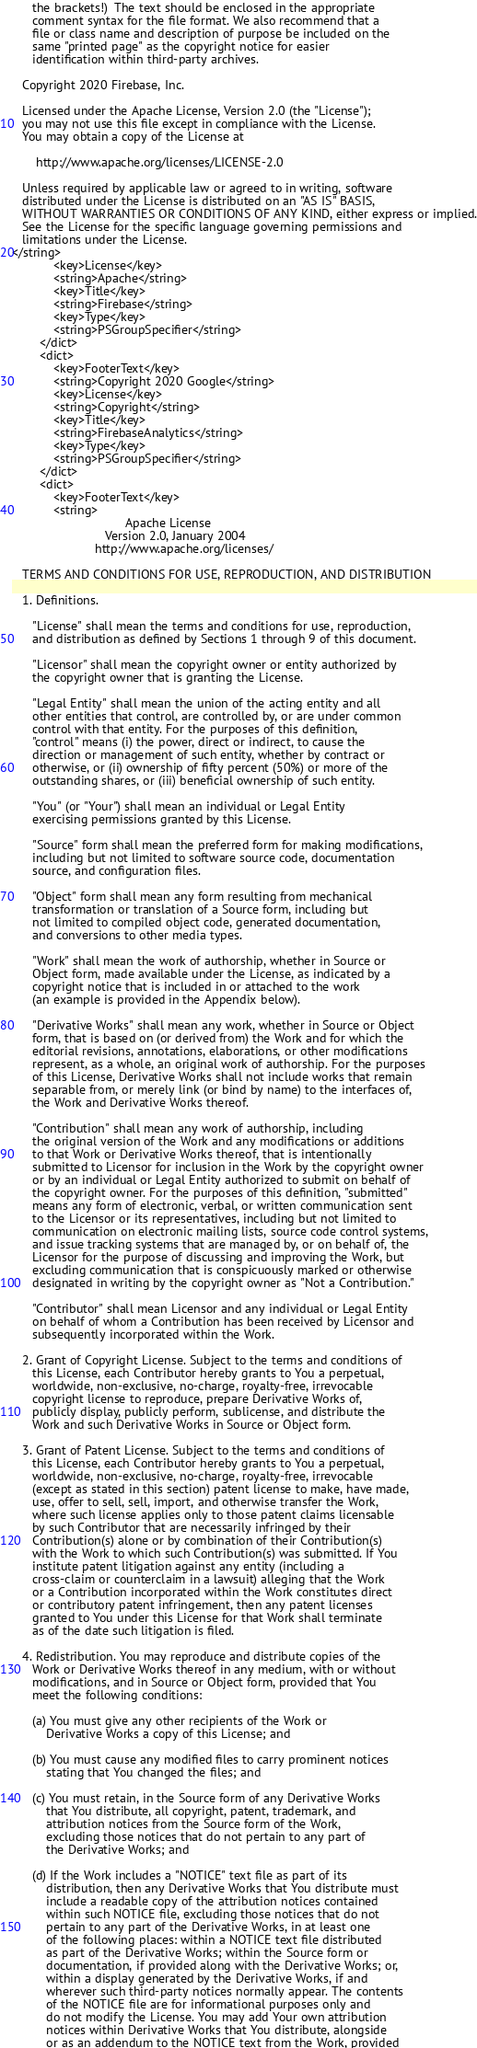Convert code to text. <code><loc_0><loc_0><loc_500><loc_500><_XML_>      the brackets!)  The text should be enclosed in the appropriate
      comment syntax for the file format. We also recommend that a
      file or class name and description of purpose be included on the
      same "printed page" as the copyright notice for easier
      identification within third-party archives.

   Copyright 2020 Firebase, Inc.

   Licensed under the Apache License, Version 2.0 (the "License");
   you may not use this file except in compliance with the License.
   You may obtain a copy of the License at

       http://www.apache.org/licenses/LICENSE-2.0

   Unless required by applicable law or agreed to in writing, software
   distributed under the License is distributed on an "AS IS" BASIS,
   WITHOUT WARRANTIES OR CONDITIONS OF ANY KIND, either express or implied.
   See the License for the specific language governing permissions and
   limitations under the License.
</string>
			<key>License</key>
			<string>Apache</string>
			<key>Title</key>
			<string>Firebase</string>
			<key>Type</key>
			<string>PSGroupSpecifier</string>
		</dict>
		<dict>
			<key>FooterText</key>
			<string>Copyright 2020 Google</string>
			<key>License</key>
			<string>Copyright</string>
			<key>Title</key>
			<string>FirebaseAnalytics</string>
			<key>Type</key>
			<string>PSGroupSpecifier</string>
		</dict>
		<dict>
			<key>FooterText</key>
			<string>
                                 Apache License
                           Version 2.0, January 2004
                        http://www.apache.org/licenses/

   TERMS AND CONDITIONS FOR USE, REPRODUCTION, AND DISTRIBUTION

   1. Definitions.

      "License" shall mean the terms and conditions for use, reproduction,
      and distribution as defined by Sections 1 through 9 of this document.

      "Licensor" shall mean the copyright owner or entity authorized by
      the copyright owner that is granting the License.

      "Legal Entity" shall mean the union of the acting entity and all
      other entities that control, are controlled by, or are under common
      control with that entity. For the purposes of this definition,
      "control" means (i) the power, direct or indirect, to cause the
      direction or management of such entity, whether by contract or
      otherwise, or (ii) ownership of fifty percent (50%) or more of the
      outstanding shares, or (iii) beneficial ownership of such entity.

      "You" (or "Your") shall mean an individual or Legal Entity
      exercising permissions granted by this License.

      "Source" form shall mean the preferred form for making modifications,
      including but not limited to software source code, documentation
      source, and configuration files.

      "Object" form shall mean any form resulting from mechanical
      transformation or translation of a Source form, including but
      not limited to compiled object code, generated documentation,
      and conversions to other media types.

      "Work" shall mean the work of authorship, whether in Source or
      Object form, made available under the License, as indicated by a
      copyright notice that is included in or attached to the work
      (an example is provided in the Appendix below).

      "Derivative Works" shall mean any work, whether in Source or Object
      form, that is based on (or derived from) the Work and for which the
      editorial revisions, annotations, elaborations, or other modifications
      represent, as a whole, an original work of authorship. For the purposes
      of this License, Derivative Works shall not include works that remain
      separable from, or merely link (or bind by name) to the interfaces of,
      the Work and Derivative Works thereof.

      "Contribution" shall mean any work of authorship, including
      the original version of the Work and any modifications or additions
      to that Work or Derivative Works thereof, that is intentionally
      submitted to Licensor for inclusion in the Work by the copyright owner
      or by an individual or Legal Entity authorized to submit on behalf of
      the copyright owner. For the purposes of this definition, "submitted"
      means any form of electronic, verbal, or written communication sent
      to the Licensor or its representatives, including but not limited to
      communication on electronic mailing lists, source code control systems,
      and issue tracking systems that are managed by, or on behalf of, the
      Licensor for the purpose of discussing and improving the Work, but
      excluding communication that is conspicuously marked or otherwise
      designated in writing by the copyright owner as "Not a Contribution."

      "Contributor" shall mean Licensor and any individual or Legal Entity
      on behalf of whom a Contribution has been received by Licensor and
      subsequently incorporated within the Work.

   2. Grant of Copyright License. Subject to the terms and conditions of
      this License, each Contributor hereby grants to You a perpetual,
      worldwide, non-exclusive, no-charge, royalty-free, irrevocable
      copyright license to reproduce, prepare Derivative Works of,
      publicly display, publicly perform, sublicense, and distribute the
      Work and such Derivative Works in Source or Object form.

   3. Grant of Patent License. Subject to the terms and conditions of
      this License, each Contributor hereby grants to You a perpetual,
      worldwide, non-exclusive, no-charge, royalty-free, irrevocable
      (except as stated in this section) patent license to make, have made,
      use, offer to sell, sell, import, and otherwise transfer the Work,
      where such license applies only to those patent claims licensable
      by such Contributor that are necessarily infringed by their
      Contribution(s) alone or by combination of their Contribution(s)
      with the Work to which such Contribution(s) was submitted. If You
      institute patent litigation against any entity (including a
      cross-claim or counterclaim in a lawsuit) alleging that the Work
      or a Contribution incorporated within the Work constitutes direct
      or contributory patent infringement, then any patent licenses
      granted to You under this License for that Work shall terminate
      as of the date such litigation is filed.

   4. Redistribution. You may reproduce and distribute copies of the
      Work or Derivative Works thereof in any medium, with or without
      modifications, and in Source or Object form, provided that You
      meet the following conditions:

      (a) You must give any other recipients of the Work or
          Derivative Works a copy of this License; and

      (b) You must cause any modified files to carry prominent notices
          stating that You changed the files; and

      (c) You must retain, in the Source form of any Derivative Works
          that You distribute, all copyright, patent, trademark, and
          attribution notices from the Source form of the Work,
          excluding those notices that do not pertain to any part of
          the Derivative Works; and

      (d) If the Work includes a "NOTICE" text file as part of its
          distribution, then any Derivative Works that You distribute must
          include a readable copy of the attribution notices contained
          within such NOTICE file, excluding those notices that do not
          pertain to any part of the Derivative Works, in at least one
          of the following places: within a NOTICE text file distributed
          as part of the Derivative Works; within the Source form or
          documentation, if provided along with the Derivative Works; or,
          within a display generated by the Derivative Works, if and
          wherever such third-party notices normally appear. The contents
          of the NOTICE file are for informational purposes only and
          do not modify the License. You may add Your own attribution
          notices within Derivative Works that You distribute, alongside
          or as an addendum to the NOTICE text from the Work, provided</code> 